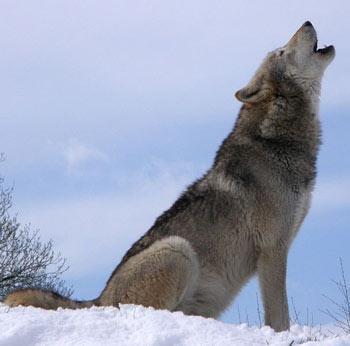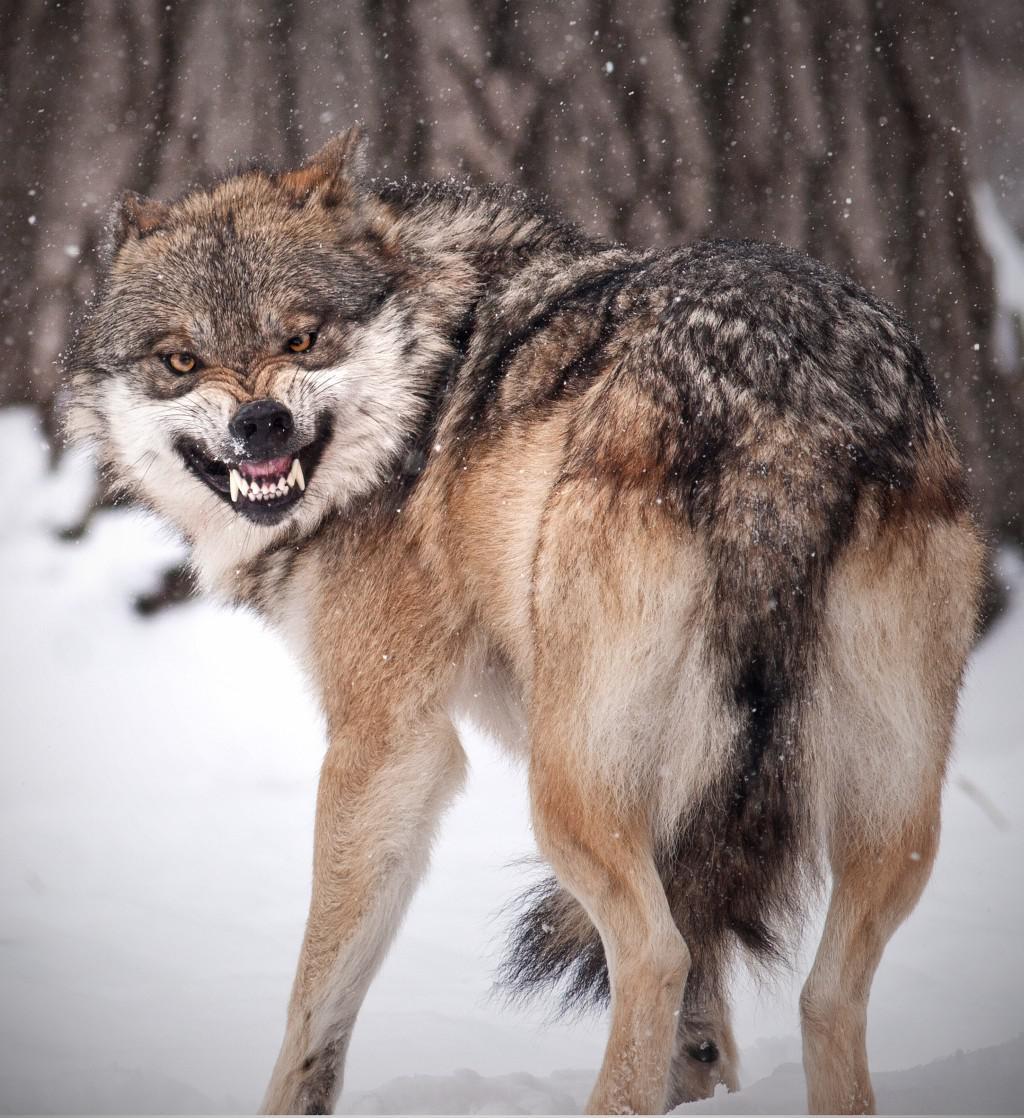The first image is the image on the left, the second image is the image on the right. Given the left and right images, does the statement "There are at least three wolves standing in the snow." hold true? Answer yes or no. No. 